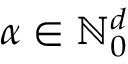Convert formula to latex. <formula><loc_0><loc_0><loc_500><loc_500>\alpha \in \mathbb { N } _ { 0 } ^ { d }</formula> 